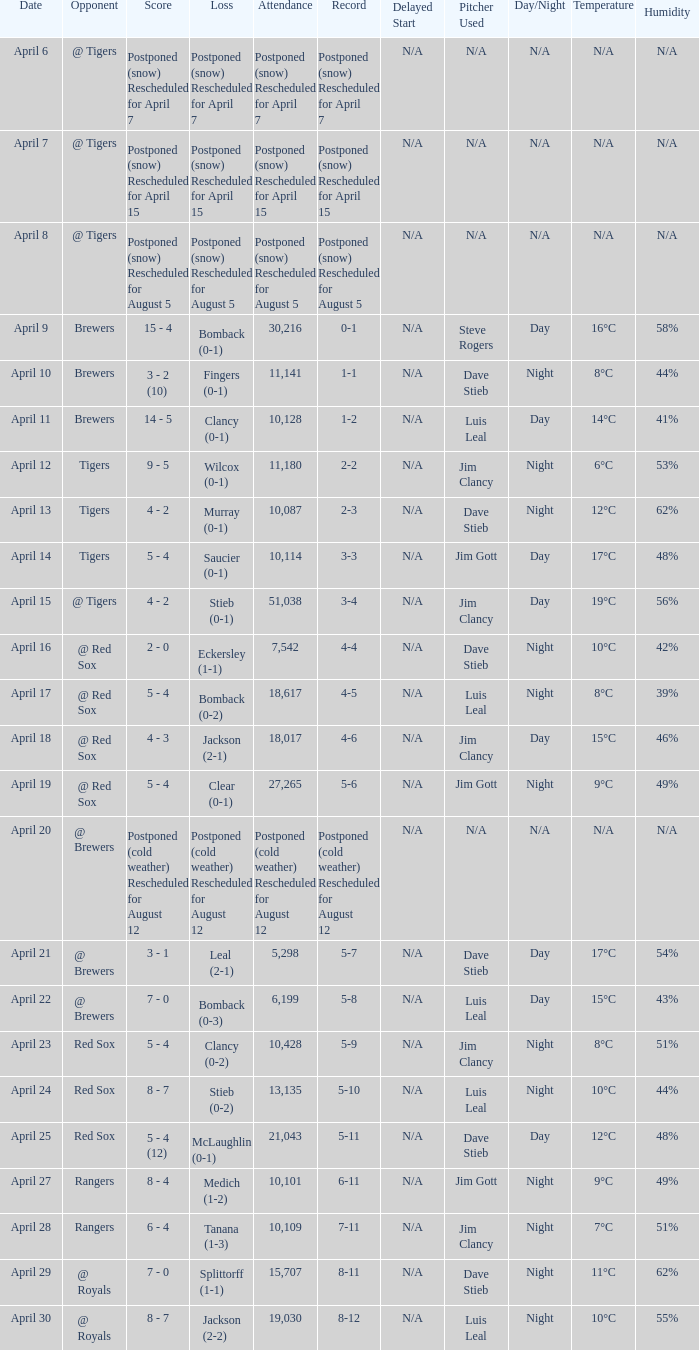What is the record for the game with an attendance of 11,141? 1-1. 